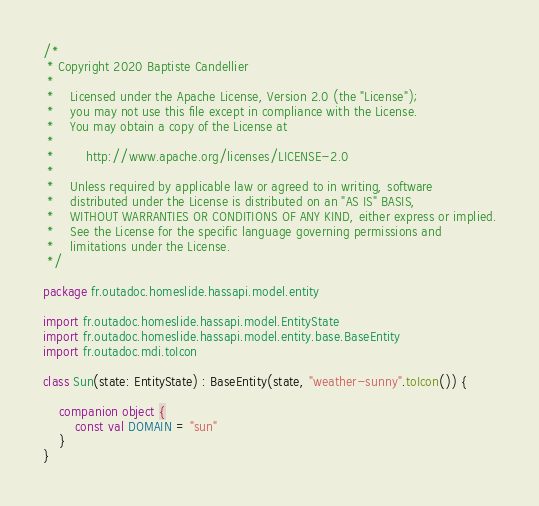Convert code to text. <code><loc_0><loc_0><loc_500><loc_500><_Kotlin_>/*
 * Copyright 2020 Baptiste Candellier
 *
 *    Licensed under the Apache License, Version 2.0 (the "License");
 *    you may not use this file except in compliance with the License.
 *    You may obtain a copy of the License at
 *
 *        http://www.apache.org/licenses/LICENSE-2.0
 *
 *    Unless required by applicable law or agreed to in writing, software
 *    distributed under the License is distributed on an "AS IS" BASIS,
 *    WITHOUT WARRANTIES OR CONDITIONS OF ANY KIND, either express or implied.
 *    See the License for the specific language governing permissions and
 *    limitations under the License.
 */

package fr.outadoc.homeslide.hassapi.model.entity

import fr.outadoc.homeslide.hassapi.model.EntityState
import fr.outadoc.homeslide.hassapi.model.entity.base.BaseEntity
import fr.outadoc.mdi.toIcon

class Sun(state: EntityState) : BaseEntity(state, "weather-sunny".toIcon()) {

    companion object {
        const val DOMAIN = "sun"
    }
}
</code> 